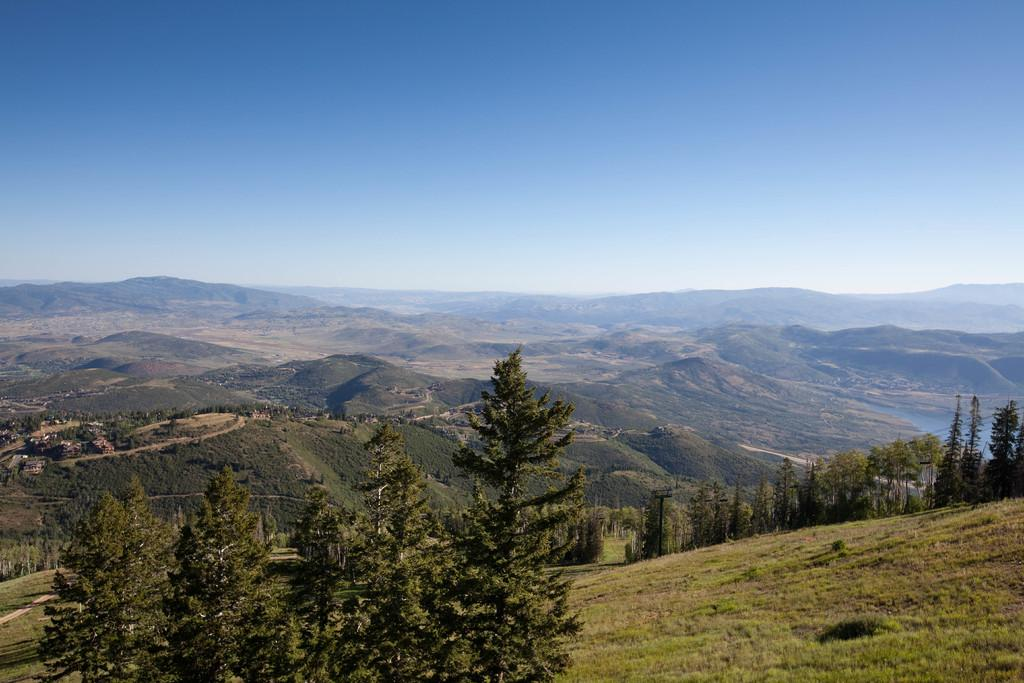What type of natural landscape can be seen in the background of the image? There are mountains in the background of the image. What type of vegetation is present in the image? There are trees in the image. What type of ground cover is visible at the bottom of the image? There is grass at the bottom of the image. What type of wood is the carpenter using to build the cherry in the image? There is no carpenter or cherry present in the image; it features a natural landscape with mountains, trees, and grass. 